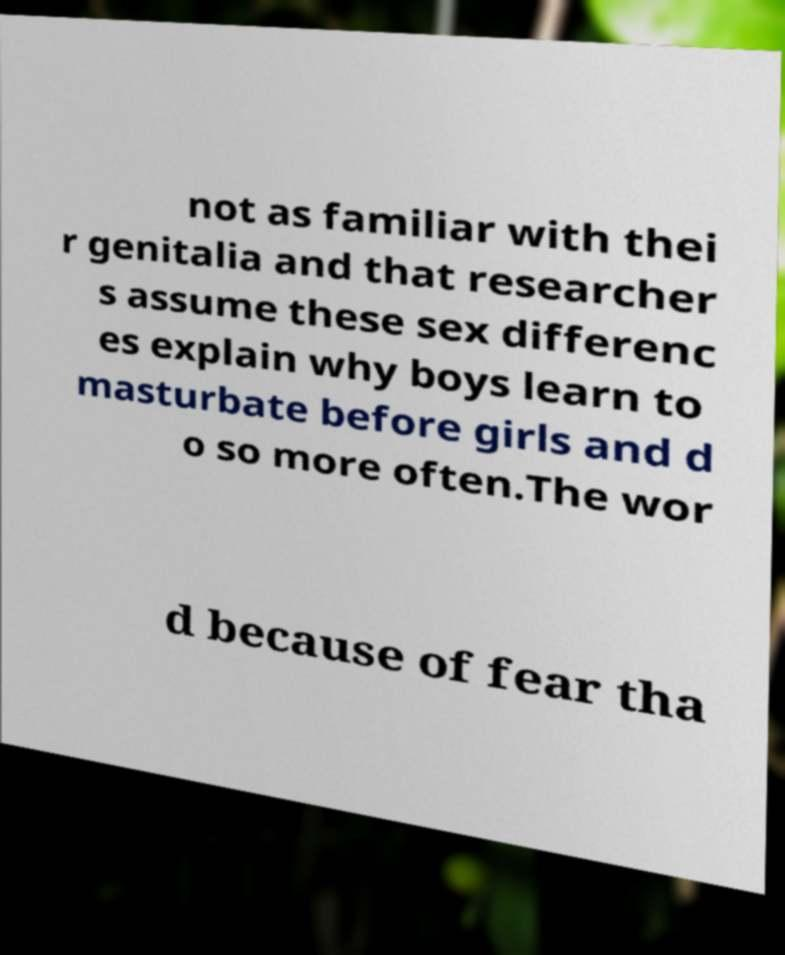There's text embedded in this image that I need extracted. Can you transcribe it verbatim? not as familiar with thei r genitalia and that researcher s assume these sex differenc es explain why boys learn to masturbate before girls and d o so more often.The wor d because of fear tha 